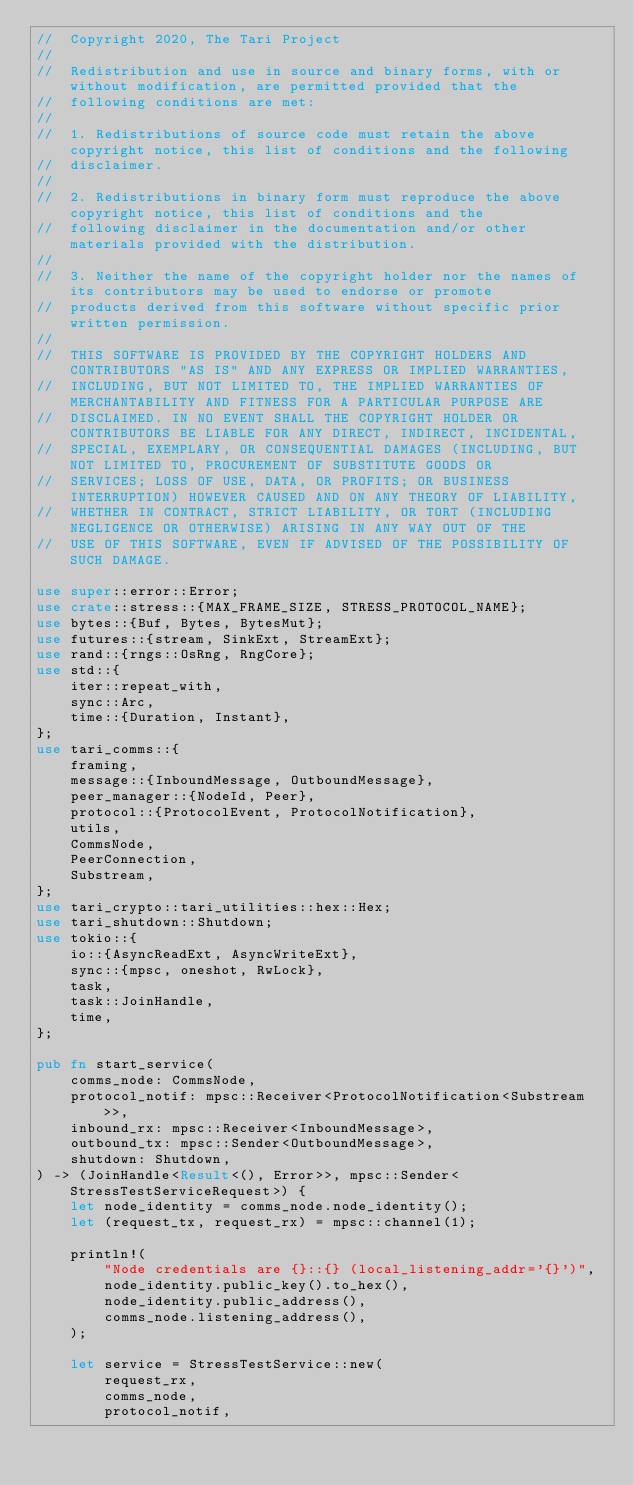Convert code to text. <code><loc_0><loc_0><loc_500><loc_500><_Rust_>//  Copyright 2020, The Tari Project
//
//  Redistribution and use in source and binary forms, with or without modification, are permitted provided that the
//  following conditions are met:
//
//  1. Redistributions of source code must retain the above copyright notice, this list of conditions and the following
//  disclaimer.
//
//  2. Redistributions in binary form must reproduce the above copyright notice, this list of conditions and the
//  following disclaimer in the documentation and/or other materials provided with the distribution.
//
//  3. Neither the name of the copyright holder nor the names of its contributors may be used to endorse or promote
//  products derived from this software without specific prior written permission.
//
//  THIS SOFTWARE IS PROVIDED BY THE COPYRIGHT HOLDERS AND CONTRIBUTORS "AS IS" AND ANY EXPRESS OR IMPLIED WARRANTIES,
//  INCLUDING, BUT NOT LIMITED TO, THE IMPLIED WARRANTIES OF MERCHANTABILITY AND FITNESS FOR A PARTICULAR PURPOSE ARE
//  DISCLAIMED. IN NO EVENT SHALL THE COPYRIGHT HOLDER OR CONTRIBUTORS BE LIABLE FOR ANY DIRECT, INDIRECT, INCIDENTAL,
//  SPECIAL, EXEMPLARY, OR CONSEQUENTIAL DAMAGES (INCLUDING, BUT NOT LIMITED TO, PROCUREMENT OF SUBSTITUTE GOODS OR
//  SERVICES; LOSS OF USE, DATA, OR PROFITS; OR BUSINESS INTERRUPTION) HOWEVER CAUSED AND ON ANY THEORY OF LIABILITY,
//  WHETHER IN CONTRACT, STRICT LIABILITY, OR TORT (INCLUDING NEGLIGENCE OR OTHERWISE) ARISING IN ANY WAY OUT OF THE
//  USE OF THIS SOFTWARE, EVEN IF ADVISED OF THE POSSIBILITY OF SUCH DAMAGE.

use super::error::Error;
use crate::stress::{MAX_FRAME_SIZE, STRESS_PROTOCOL_NAME};
use bytes::{Buf, Bytes, BytesMut};
use futures::{stream, SinkExt, StreamExt};
use rand::{rngs::OsRng, RngCore};
use std::{
    iter::repeat_with,
    sync::Arc,
    time::{Duration, Instant},
};
use tari_comms::{
    framing,
    message::{InboundMessage, OutboundMessage},
    peer_manager::{NodeId, Peer},
    protocol::{ProtocolEvent, ProtocolNotification},
    utils,
    CommsNode,
    PeerConnection,
    Substream,
};
use tari_crypto::tari_utilities::hex::Hex;
use tari_shutdown::Shutdown;
use tokio::{
    io::{AsyncReadExt, AsyncWriteExt},
    sync::{mpsc, oneshot, RwLock},
    task,
    task::JoinHandle,
    time,
};

pub fn start_service(
    comms_node: CommsNode,
    protocol_notif: mpsc::Receiver<ProtocolNotification<Substream>>,
    inbound_rx: mpsc::Receiver<InboundMessage>,
    outbound_tx: mpsc::Sender<OutboundMessage>,
    shutdown: Shutdown,
) -> (JoinHandle<Result<(), Error>>, mpsc::Sender<StressTestServiceRequest>) {
    let node_identity = comms_node.node_identity();
    let (request_tx, request_rx) = mpsc::channel(1);

    println!(
        "Node credentials are {}::{} (local_listening_addr='{}')",
        node_identity.public_key().to_hex(),
        node_identity.public_address(),
        comms_node.listening_address(),
    );

    let service = StressTestService::new(
        request_rx,
        comms_node,
        protocol_notif,</code> 